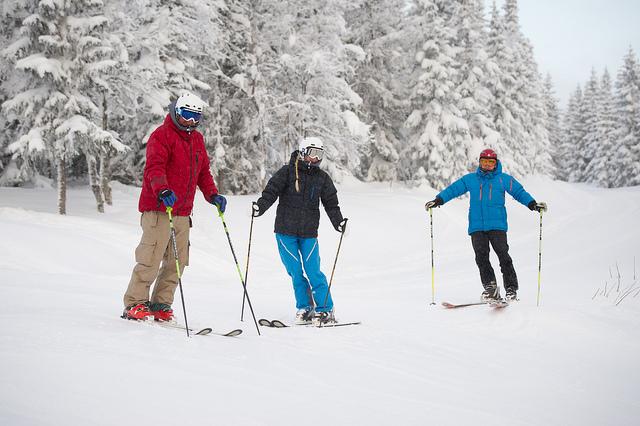Is the tallest person male or female?
Give a very brief answer. Male. How many people have pants and coat that are the same color?
Write a very short answer. 0. Does one person have a red coat?
Short answer required. Yes. 